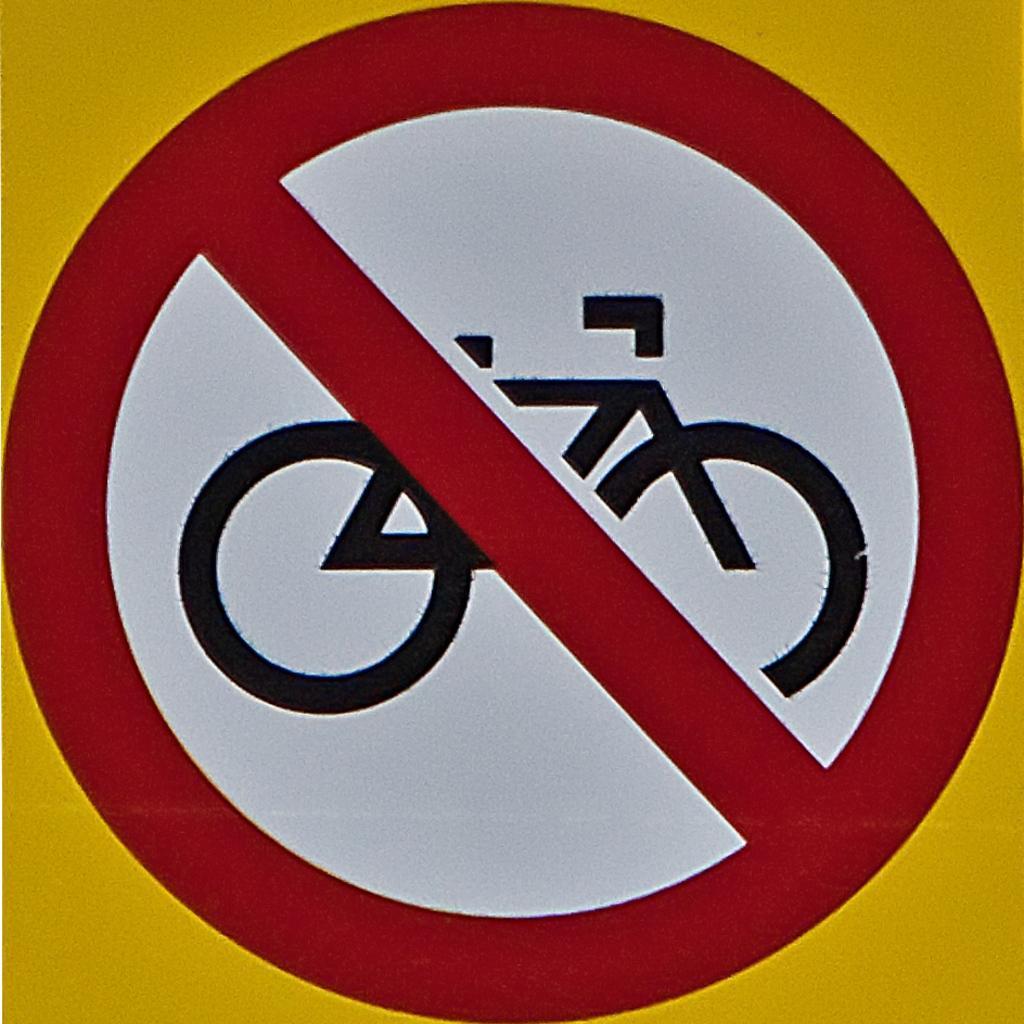In one or two sentences, can you explain what this image depicts? In the foreground of this image, there is a stop sign board in which no bicycles are allowed. 